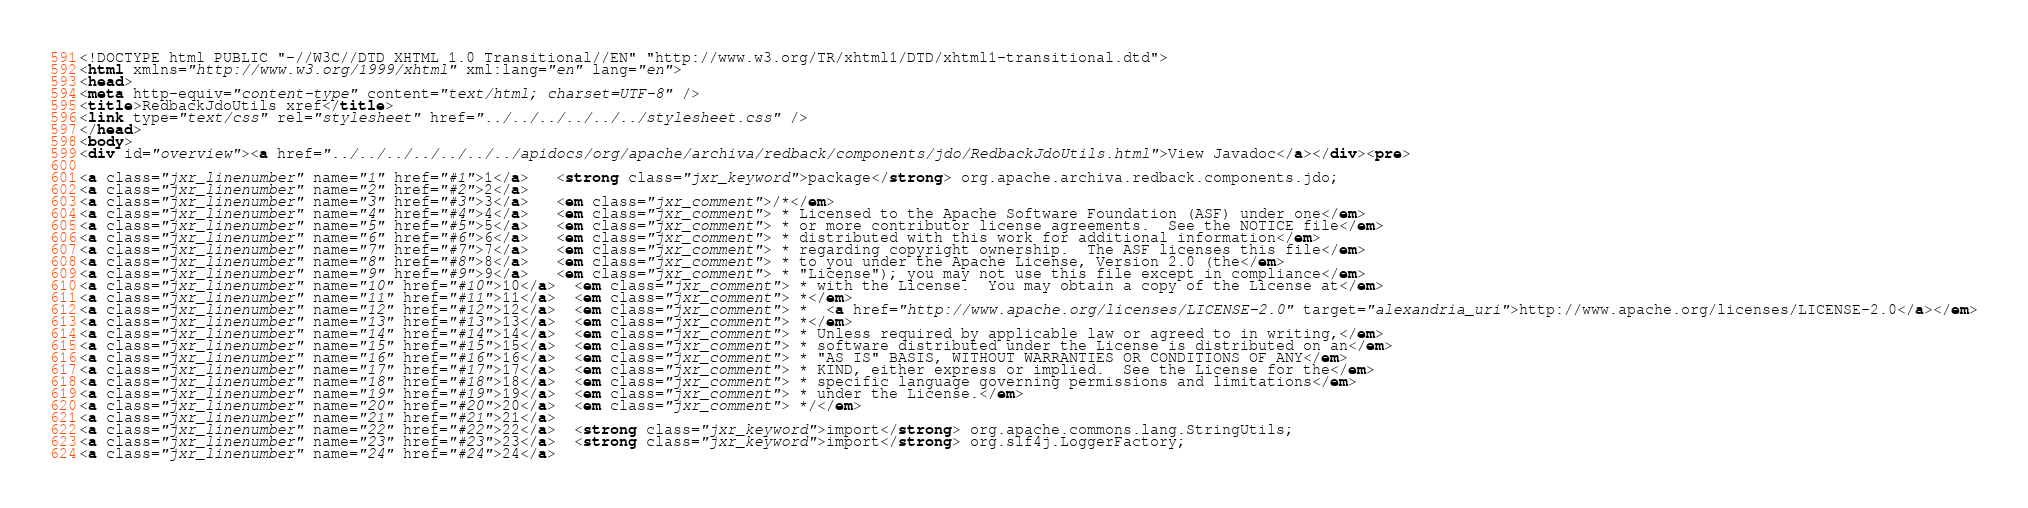Convert code to text. <code><loc_0><loc_0><loc_500><loc_500><_HTML_><!DOCTYPE html PUBLIC "-//W3C//DTD XHTML 1.0 Transitional//EN" "http://www.w3.org/TR/xhtml1/DTD/xhtml1-transitional.dtd">
<html xmlns="http://www.w3.org/1999/xhtml" xml:lang="en" lang="en">
<head>
<meta http-equiv="content-type" content="text/html; charset=UTF-8" />
<title>RedbackJdoUtils xref</title>
<link type="text/css" rel="stylesheet" href="../../../../../../stylesheet.css" />
</head>
<body>
<div id="overview"><a href="../../../../../../../apidocs/org/apache/archiva/redback/components/jdo/RedbackJdoUtils.html">View Javadoc</a></div><pre>

<a class="jxr_linenumber" name="1" href="#1">1</a>   <strong class="jxr_keyword">package</strong> org.apache.archiva.redback.components.jdo;
<a class="jxr_linenumber" name="2" href="#2">2</a>   
<a class="jxr_linenumber" name="3" href="#3">3</a>   <em class="jxr_comment">/*</em>
<a class="jxr_linenumber" name="4" href="#4">4</a>   <em class="jxr_comment"> * Licensed to the Apache Software Foundation (ASF) under one</em>
<a class="jxr_linenumber" name="5" href="#5">5</a>   <em class="jxr_comment"> * or more contributor license agreements.  See the NOTICE file</em>
<a class="jxr_linenumber" name="6" href="#6">6</a>   <em class="jxr_comment"> * distributed with this work for additional information</em>
<a class="jxr_linenumber" name="7" href="#7">7</a>   <em class="jxr_comment"> * regarding copyright ownership.  The ASF licenses this file</em>
<a class="jxr_linenumber" name="8" href="#8">8</a>   <em class="jxr_comment"> * to you under the Apache License, Version 2.0 (the</em>
<a class="jxr_linenumber" name="9" href="#9">9</a>   <em class="jxr_comment"> * "License"); you may not use this file except in compliance</em>
<a class="jxr_linenumber" name="10" href="#10">10</a>  <em class="jxr_comment"> * with the License.  You may obtain a copy of the License at</em>
<a class="jxr_linenumber" name="11" href="#11">11</a>  <em class="jxr_comment"> *</em>
<a class="jxr_linenumber" name="12" href="#12">12</a>  <em class="jxr_comment"> *  <a href="http://www.apache.org/licenses/LICENSE-2.0" target="alexandria_uri">http://www.apache.org/licenses/LICENSE-2.0</a></em>
<a class="jxr_linenumber" name="13" href="#13">13</a>  <em class="jxr_comment"> *</em>
<a class="jxr_linenumber" name="14" href="#14">14</a>  <em class="jxr_comment"> * Unless required by applicable law or agreed to in writing,</em>
<a class="jxr_linenumber" name="15" href="#15">15</a>  <em class="jxr_comment"> * software distributed under the License is distributed on an</em>
<a class="jxr_linenumber" name="16" href="#16">16</a>  <em class="jxr_comment"> * "AS IS" BASIS, WITHOUT WARRANTIES OR CONDITIONS OF ANY</em>
<a class="jxr_linenumber" name="17" href="#17">17</a>  <em class="jxr_comment"> * KIND, either express or implied.  See the License for the</em>
<a class="jxr_linenumber" name="18" href="#18">18</a>  <em class="jxr_comment"> * specific language governing permissions and limitations</em>
<a class="jxr_linenumber" name="19" href="#19">19</a>  <em class="jxr_comment"> * under the License.</em>
<a class="jxr_linenumber" name="20" href="#20">20</a>  <em class="jxr_comment"> */</em>
<a class="jxr_linenumber" name="21" href="#21">21</a>  
<a class="jxr_linenumber" name="22" href="#22">22</a>  <strong class="jxr_keyword">import</strong> org.apache.commons.lang.StringUtils;
<a class="jxr_linenumber" name="23" href="#23">23</a>  <strong class="jxr_keyword">import</strong> org.slf4j.LoggerFactory;
<a class="jxr_linenumber" name="24" href="#24">24</a>  </code> 